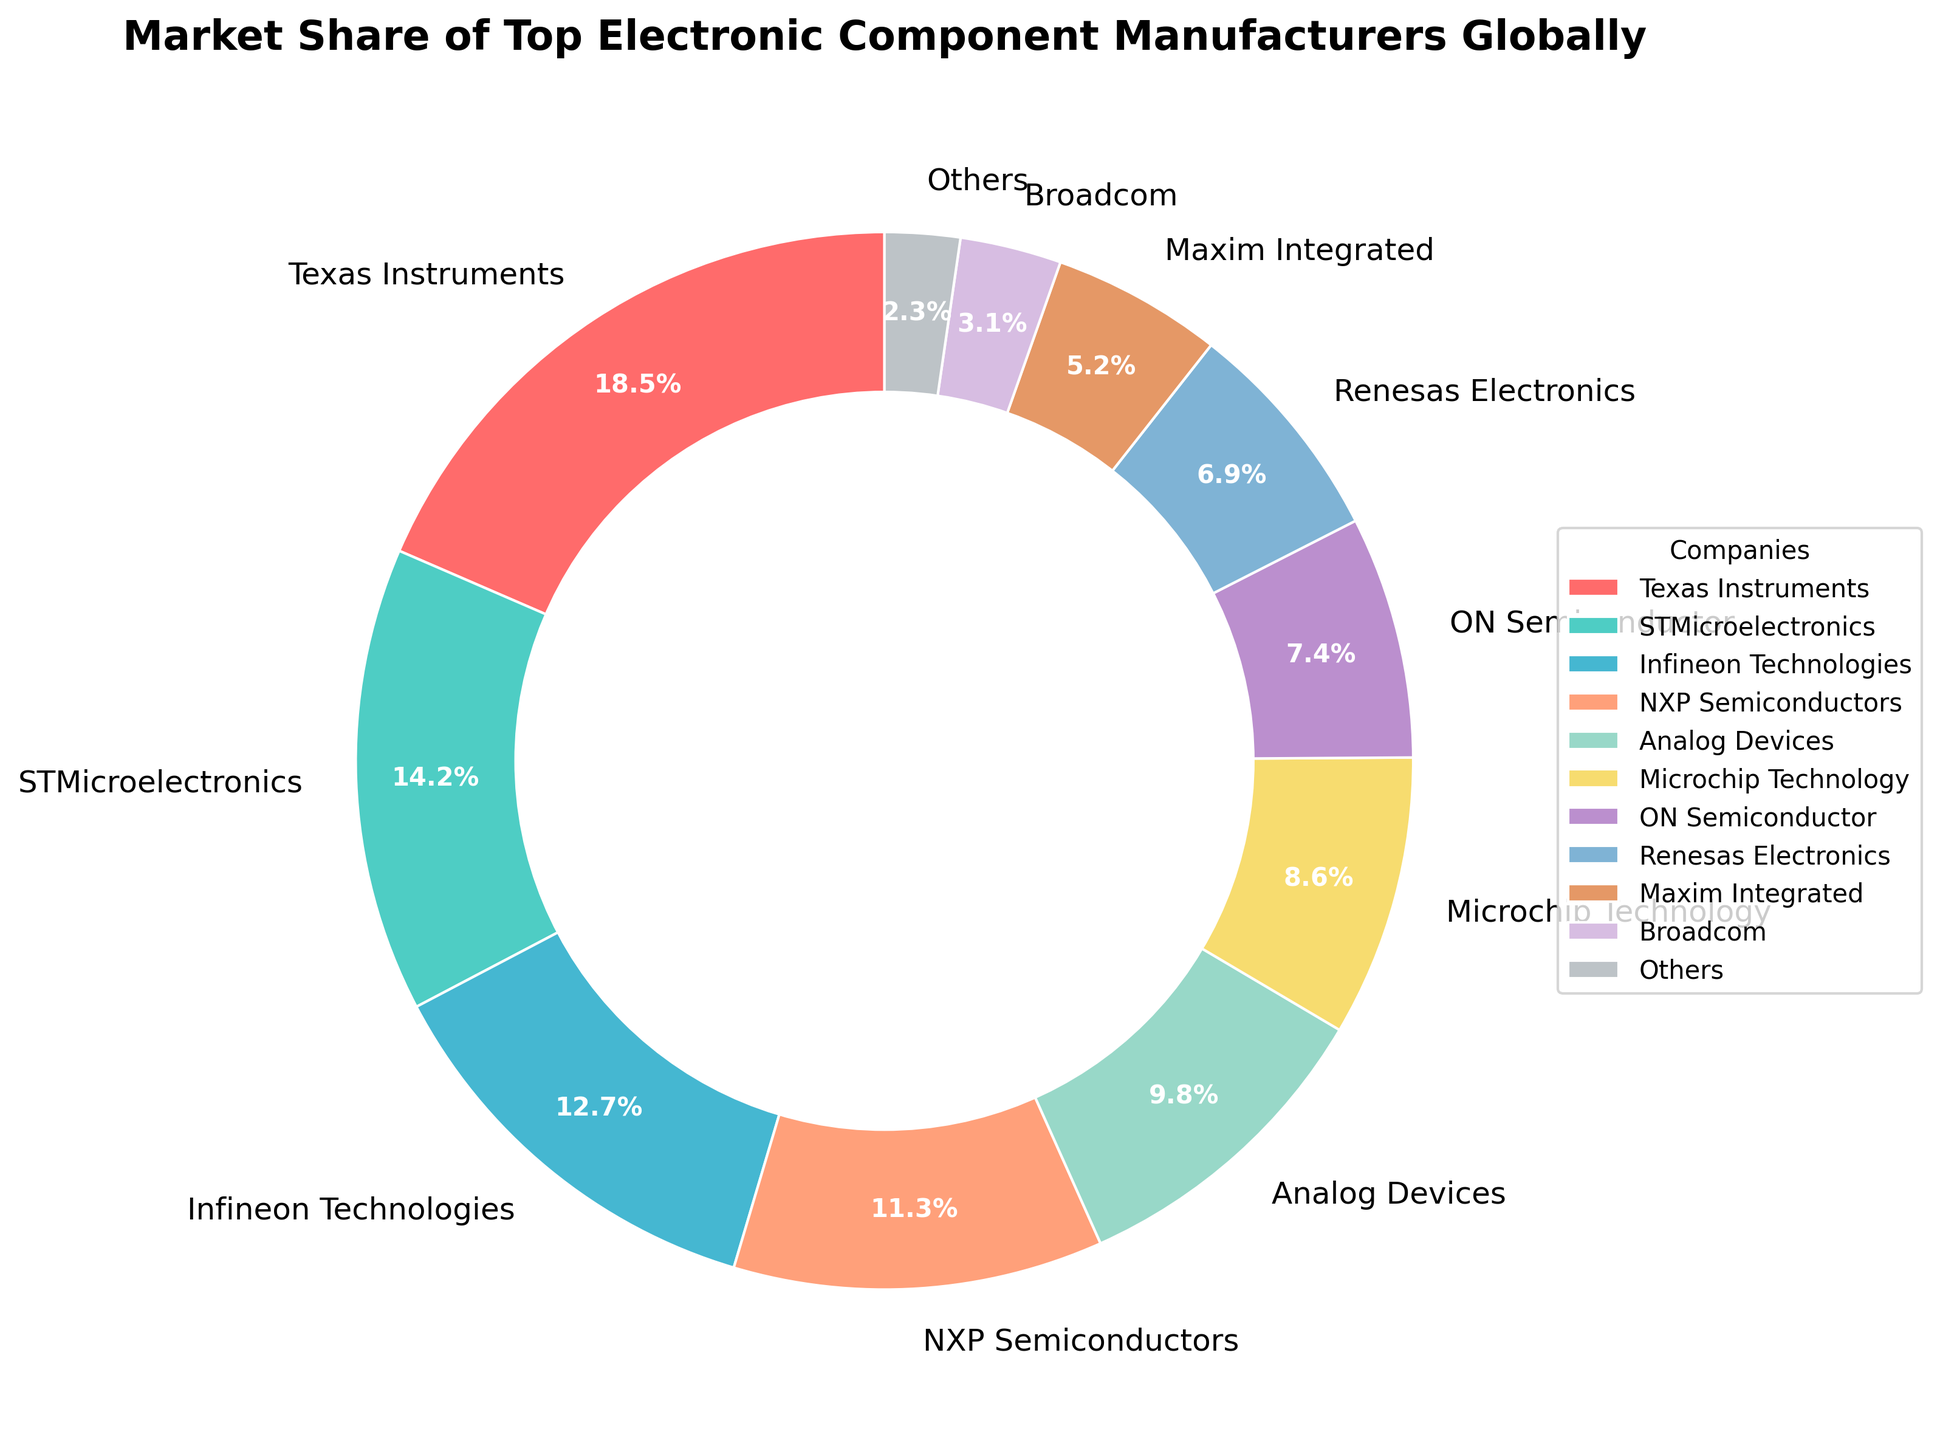What is the market share of Texas Instruments? Texas Instruments has a slice labeled with 18.5%, indicating its market share is 18.5%
Answer: 18.5% Which company has the smallest market share among the listed companies? Broadcom has the smallest slice with 3.1%, making it the company with the smallest market share
Answer: Broadcom How much larger is the market share of Texas Instruments compared to Broadcom? Texas Instruments has 18.5% while Broadcom has 3.1%. Subtracting 3.1% from 18.5% results in a difference of 15.4%
Answer: 15.4% Which companies have a market share greater than 10%? Texas Instruments (18.5%), STMicroelectronics (14.2%), Infineon Technologies (12.7%), and NXP Semiconductors (11.3%) all have market shares greater than 10%
Answer: Texas Instruments, STMicroelectronics, Infineon Technologies, NXP Semiconductors How many companies are represented in the 'Others' category, and what is their combined market share? The 'Others' category represents multiple companies combining to a market share of 2.3% as indicated by the 'Others' slice
Answer: Multiple companies, 2.3% Which company has a market share closest to 10%? Analog Devices has a market share of 9.8%, which is the closest to 10%
Answer: Analog Devices What is the total market share of the top three companies? The top three companies are Texas Instruments (18.5%), STMicroelectronics (14.2%), and Infineon Technologies (12.7%). Summing these values gives 18.5% + 14.2% + 12.7% = 45.4%
Answer: 45.4% Is the combined market share of NXP Semiconductors and Microchip Technology greater than that of Texas Instruments? NXP Semiconductors (11.3%) and Microchip Technology (8.6%) combined is 11.3% + 8.6% = 19.9%, which is greater than Texas Instruments' 18.5%
Answer: Yes What is the difference in market share between the companies with the largest and smallest shares? Texas Instruments (18.5%) has the largest share, and Broadcom (3.1%) the smallest. The difference is 18.5% - 3.1% = 15.4%
Answer: 15.4% Which company has a market share represented by a greenish color wedge? The greenish color wedge is associated with STMicroelectronics, having a market share of 14.2%
Answer: STMicroelectronics 